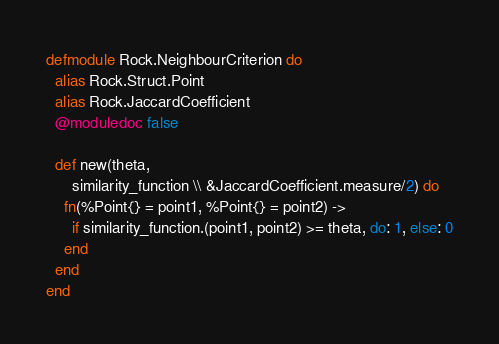<code> <loc_0><loc_0><loc_500><loc_500><_Elixir_>defmodule Rock.NeighbourCriterion do
  alias Rock.Struct.Point
  alias Rock.JaccardCoefficient
  @moduledoc false

  def new(theta,
      similarity_function \\ &JaccardCoefficient.measure/2) do
    fn(%Point{} = point1, %Point{} = point2) ->
      if similarity_function.(point1, point2) >= theta, do: 1, else: 0
    end
  end
end
</code> 